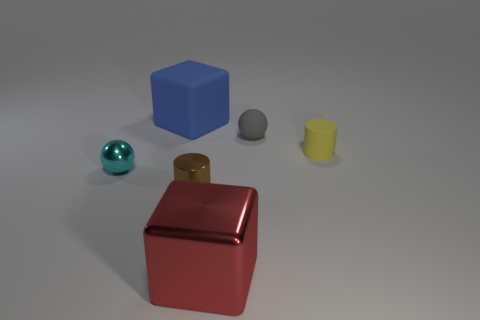Is the size of the rubber sphere the same as the rubber thing that is to the left of the large red metal thing?
Provide a succinct answer. No. There is a object that is both in front of the gray object and right of the large metallic thing; what size is it?
Provide a short and direct response. Small. How many metallic cubes are the same color as the matte cylinder?
Offer a very short reply. 0. What is the material of the cyan object?
Your answer should be very brief. Metal. Is the big object on the left side of the big red shiny object made of the same material as the red object?
Make the answer very short. No. There is a matte object that is left of the red metal block; what is its shape?
Ensure brevity in your answer.  Cube. There is another sphere that is the same size as the gray ball; what is its material?
Your answer should be compact. Metal. How many things are cubes in front of the big blue cube or big objects that are in front of the yellow matte thing?
Offer a terse response. 1. What is the size of the gray sphere that is made of the same material as the blue object?
Keep it short and to the point. Small. What number of metal objects are either brown things or gray objects?
Your answer should be compact. 1. 